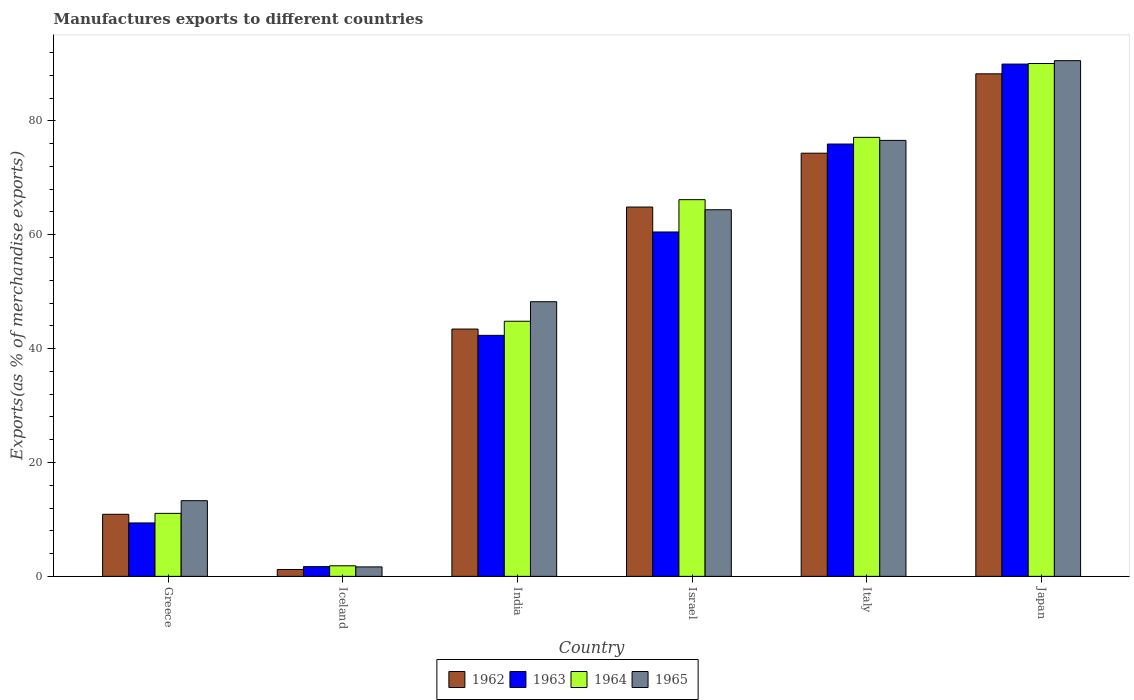How many different coloured bars are there?
Provide a short and direct response. 4. How many groups of bars are there?
Keep it short and to the point. 6. What is the percentage of exports to different countries in 1962 in Israel?
Make the answer very short. 64.86. Across all countries, what is the maximum percentage of exports to different countries in 1963?
Your response must be concise. 89.97. Across all countries, what is the minimum percentage of exports to different countries in 1965?
Make the answer very short. 1.66. In which country was the percentage of exports to different countries in 1965 maximum?
Keep it short and to the point. Japan. In which country was the percentage of exports to different countries in 1962 minimum?
Ensure brevity in your answer.  Iceland. What is the total percentage of exports to different countries in 1964 in the graph?
Provide a succinct answer. 291.06. What is the difference between the percentage of exports to different countries in 1964 in Iceland and that in Israel?
Give a very brief answer. -64.3. What is the difference between the percentage of exports to different countries in 1964 in Iceland and the percentage of exports to different countries in 1962 in Japan?
Give a very brief answer. -86.4. What is the average percentage of exports to different countries in 1965 per country?
Your response must be concise. 49.12. What is the difference between the percentage of exports to different countries of/in 1963 and percentage of exports to different countries of/in 1962 in Italy?
Your response must be concise. 1.61. In how many countries, is the percentage of exports to different countries in 1965 greater than 64 %?
Keep it short and to the point. 3. What is the ratio of the percentage of exports to different countries in 1964 in Iceland to that in India?
Offer a very short reply. 0.04. Is the percentage of exports to different countries in 1964 in Iceland less than that in Italy?
Your response must be concise. Yes. Is the difference between the percentage of exports to different countries in 1963 in Israel and Japan greater than the difference between the percentage of exports to different countries in 1962 in Israel and Japan?
Ensure brevity in your answer.  No. What is the difference between the highest and the second highest percentage of exports to different countries in 1963?
Your answer should be very brief. 14.04. What is the difference between the highest and the lowest percentage of exports to different countries in 1963?
Make the answer very short. 88.26. What does the 3rd bar from the left in Japan represents?
Offer a terse response. 1964. Is it the case that in every country, the sum of the percentage of exports to different countries in 1962 and percentage of exports to different countries in 1965 is greater than the percentage of exports to different countries in 1964?
Your response must be concise. Yes. How many bars are there?
Make the answer very short. 24. What is the difference between two consecutive major ticks on the Y-axis?
Provide a succinct answer. 20. Are the values on the major ticks of Y-axis written in scientific E-notation?
Ensure brevity in your answer.  No. Does the graph contain any zero values?
Keep it short and to the point. No. What is the title of the graph?
Your response must be concise. Manufactures exports to different countries. Does "1967" appear as one of the legend labels in the graph?
Make the answer very short. No. What is the label or title of the Y-axis?
Offer a very short reply. Exports(as % of merchandise exports). What is the Exports(as % of merchandise exports) in 1962 in Greece?
Provide a short and direct response. 10.9. What is the Exports(as % of merchandise exports) in 1963 in Greece?
Your answer should be compact. 9.38. What is the Exports(as % of merchandise exports) of 1964 in Greece?
Keep it short and to the point. 11.06. What is the Exports(as % of merchandise exports) in 1965 in Greece?
Provide a succinct answer. 13.29. What is the Exports(as % of merchandise exports) in 1962 in Iceland?
Your answer should be compact. 1.21. What is the Exports(as % of merchandise exports) in 1963 in Iceland?
Give a very brief answer. 1.71. What is the Exports(as % of merchandise exports) in 1964 in Iceland?
Keep it short and to the point. 1.86. What is the Exports(as % of merchandise exports) of 1965 in Iceland?
Provide a succinct answer. 1.66. What is the Exports(as % of merchandise exports) in 1962 in India?
Provide a short and direct response. 43.43. What is the Exports(as % of merchandise exports) of 1963 in India?
Your answer should be compact. 42.33. What is the Exports(as % of merchandise exports) of 1964 in India?
Make the answer very short. 44.81. What is the Exports(as % of merchandise exports) of 1965 in India?
Ensure brevity in your answer.  48.24. What is the Exports(as % of merchandise exports) in 1962 in Israel?
Provide a short and direct response. 64.86. What is the Exports(as % of merchandise exports) of 1963 in Israel?
Offer a terse response. 60.48. What is the Exports(as % of merchandise exports) in 1964 in Israel?
Ensure brevity in your answer.  66.16. What is the Exports(as % of merchandise exports) of 1965 in Israel?
Your response must be concise. 64.39. What is the Exports(as % of merchandise exports) of 1962 in Italy?
Provide a short and direct response. 74.32. What is the Exports(as % of merchandise exports) in 1963 in Italy?
Your answer should be compact. 75.93. What is the Exports(as % of merchandise exports) of 1964 in Italy?
Ensure brevity in your answer.  77.1. What is the Exports(as % of merchandise exports) of 1965 in Italy?
Your answer should be very brief. 76.57. What is the Exports(as % of merchandise exports) of 1962 in Japan?
Ensure brevity in your answer.  88.26. What is the Exports(as % of merchandise exports) of 1963 in Japan?
Keep it short and to the point. 89.97. What is the Exports(as % of merchandise exports) of 1964 in Japan?
Your answer should be compact. 90.07. What is the Exports(as % of merchandise exports) of 1965 in Japan?
Give a very brief answer. 90.57. Across all countries, what is the maximum Exports(as % of merchandise exports) in 1962?
Offer a very short reply. 88.26. Across all countries, what is the maximum Exports(as % of merchandise exports) of 1963?
Offer a terse response. 89.97. Across all countries, what is the maximum Exports(as % of merchandise exports) of 1964?
Give a very brief answer. 90.07. Across all countries, what is the maximum Exports(as % of merchandise exports) in 1965?
Your response must be concise. 90.57. Across all countries, what is the minimum Exports(as % of merchandise exports) of 1962?
Offer a very short reply. 1.21. Across all countries, what is the minimum Exports(as % of merchandise exports) in 1963?
Provide a short and direct response. 1.71. Across all countries, what is the minimum Exports(as % of merchandise exports) of 1964?
Ensure brevity in your answer.  1.86. Across all countries, what is the minimum Exports(as % of merchandise exports) of 1965?
Your answer should be very brief. 1.66. What is the total Exports(as % of merchandise exports) in 1962 in the graph?
Ensure brevity in your answer.  282.99. What is the total Exports(as % of merchandise exports) in 1963 in the graph?
Give a very brief answer. 279.8. What is the total Exports(as % of merchandise exports) in 1964 in the graph?
Keep it short and to the point. 291.06. What is the total Exports(as % of merchandise exports) of 1965 in the graph?
Make the answer very short. 294.72. What is the difference between the Exports(as % of merchandise exports) of 1962 in Greece and that in Iceland?
Ensure brevity in your answer.  9.69. What is the difference between the Exports(as % of merchandise exports) in 1963 in Greece and that in Iceland?
Give a very brief answer. 7.67. What is the difference between the Exports(as % of merchandise exports) of 1964 in Greece and that in Iceland?
Your response must be concise. 9.21. What is the difference between the Exports(as % of merchandise exports) of 1965 in Greece and that in Iceland?
Make the answer very short. 11.63. What is the difference between the Exports(as % of merchandise exports) in 1962 in Greece and that in India?
Keep it short and to the point. -32.53. What is the difference between the Exports(as % of merchandise exports) in 1963 in Greece and that in India?
Your answer should be very brief. -32.95. What is the difference between the Exports(as % of merchandise exports) in 1964 in Greece and that in India?
Your response must be concise. -33.74. What is the difference between the Exports(as % of merchandise exports) of 1965 in Greece and that in India?
Provide a succinct answer. -34.95. What is the difference between the Exports(as % of merchandise exports) of 1962 in Greece and that in Israel?
Give a very brief answer. -53.96. What is the difference between the Exports(as % of merchandise exports) of 1963 in Greece and that in Israel?
Your answer should be very brief. -51.1. What is the difference between the Exports(as % of merchandise exports) of 1964 in Greece and that in Israel?
Ensure brevity in your answer.  -55.1. What is the difference between the Exports(as % of merchandise exports) of 1965 in Greece and that in Israel?
Your answer should be very brief. -51.1. What is the difference between the Exports(as % of merchandise exports) in 1962 in Greece and that in Italy?
Give a very brief answer. -63.42. What is the difference between the Exports(as % of merchandise exports) in 1963 in Greece and that in Italy?
Your response must be concise. -66.55. What is the difference between the Exports(as % of merchandise exports) in 1964 in Greece and that in Italy?
Ensure brevity in your answer.  -66.04. What is the difference between the Exports(as % of merchandise exports) of 1965 in Greece and that in Italy?
Provide a succinct answer. -63.28. What is the difference between the Exports(as % of merchandise exports) in 1962 in Greece and that in Japan?
Give a very brief answer. -77.36. What is the difference between the Exports(as % of merchandise exports) of 1963 in Greece and that in Japan?
Your answer should be compact. -80.59. What is the difference between the Exports(as % of merchandise exports) in 1964 in Greece and that in Japan?
Ensure brevity in your answer.  -79.01. What is the difference between the Exports(as % of merchandise exports) in 1965 in Greece and that in Japan?
Provide a succinct answer. -77.28. What is the difference between the Exports(as % of merchandise exports) in 1962 in Iceland and that in India?
Provide a short and direct response. -42.22. What is the difference between the Exports(as % of merchandise exports) in 1963 in Iceland and that in India?
Provide a short and direct response. -40.62. What is the difference between the Exports(as % of merchandise exports) of 1964 in Iceland and that in India?
Offer a very short reply. -42.95. What is the difference between the Exports(as % of merchandise exports) in 1965 in Iceland and that in India?
Your answer should be compact. -46.57. What is the difference between the Exports(as % of merchandise exports) of 1962 in Iceland and that in Israel?
Your response must be concise. -63.65. What is the difference between the Exports(as % of merchandise exports) in 1963 in Iceland and that in Israel?
Make the answer very short. -58.77. What is the difference between the Exports(as % of merchandise exports) in 1964 in Iceland and that in Israel?
Provide a short and direct response. -64.3. What is the difference between the Exports(as % of merchandise exports) in 1965 in Iceland and that in Israel?
Offer a very short reply. -62.73. What is the difference between the Exports(as % of merchandise exports) of 1962 in Iceland and that in Italy?
Your answer should be compact. -73.11. What is the difference between the Exports(as % of merchandise exports) in 1963 in Iceland and that in Italy?
Provide a succinct answer. -74.22. What is the difference between the Exports(as % of merchandise exports) of 1964 in Iceland and that in Italy?
Your answer should be very brief. -75.25. What is the difference between the Exports(as % of merchandise exports) in 1965 in Iceland and that in Italy?
Your answer should be compact. -74.9. What is the difference between the Exports(as % of merchandise exports) of 1962 in Iceland and that in Japan?
Give a very brief answer. -87.05. What is the difference between the Exports(as % of merchandise exports) in 1963 in Iceland and that in Japan?
Keep it short and to the point. -88.26. What is the difference between the Exports(as % of merchandise exports) of 1964 in Iceland and that in Japan?
Give a very brief answer. -88.22. What is the difference between the Exports(as % of merchandise exports) in 1965 in Iceland and that in Japan?
Your answer should be very brief. -88.91. What is the difference between the Exports(as % of merchandise exports) in 1962 in India and that in Israel?
Your response must be concise. -21.43. What is the difference between the Exports(as % of merchandise exports) in 1963 in India and that in Israel?
Provide a succinct answer. -18.15. What is the difference between the Exports(as % of merchandise exports) in 1964 in India and that in Israel?
Give a very brief answer. -21.35. What is the difference between the Exports(as % of merchandise exports) in 1965 in India and that in Israel?
Give a very brief answer. -16.15. What is the difference between the Exports(as % of merchandise exports) of 1962 in India and that in Italy?
Your response must be concise. -30.89. What is the difference between the Exports(as % of merchandise exports) of 1963 in India and that in Italy?
Keep it short and to the point. -33.6. What is the difference between the Exports(as % of merchandise exports) of 1964 in India and that in Italy?
Your answer should be compact. -32.3. What is the difference between the Exports(as % of merchandise exports) in 1965 in India and that in Italy?
Keep it short and to the point. -28.33. What is the difference between the Exports(as % of merchandise exports) of 1962 in India and that in Japan?
Provide a short and direct response. -44.83. What is the difference between the Exports(as % of merchandise exports) of 1963 in India and that in Japan?
Give a very brief answer. -47.64. What is the difference between the Exports(as % of merchandise exports) of 1964 in India and that in Japan?
Keep it short and to the point. -45.26. What is the difference between the Exports(as % of merchandise exports) in 1965 in India and that in Japan?
Give a very brief answer. -42.34. What is the difference between the Exports(as % of merchandise exports) in 1962 in Israel and that in Italy?
Offer a terse response. -9.46. What is the difference between the Exports(as % of merchandise exports) of 1963 in Israel and that in Italy?
Provide a short and direct response. -15.45. What is the difference between the Exports(as % of merchandise exports) in 1964 in Israel and that in Italy?
Provide a succinct answer. -10.94. What is the difference between the Exports(as % of merchandise exports) in 1965 in Israel and that in Italy?
Give a very brief answer. -12.18. What is the difference between the Exports(as % of merchandise exports) in 1962 in Israel and that in Japan?
Give a very brief answer. -23.4. What is the difference between the Exports(as % of merchandise exports) of 1963 in Israel and that in Japan?
Keep it short and to the point. -29.49. What is the difference between the Exports(as % of merchandise exports) in 1964 in Israel and that in Japan?
Your answer should be very brief. -23.91. What is the difference between the Exports(as % of merchandise exports) in 1965 in Israel and that in Japan?
Provide a short and direct response. -26.18. What is the difference between the Exports(as % of merchandise exports) of 1962 in Italy and that in Japan?
Your answer should be very brief. -13.94. What is the difference between the Exports(as % of merchandise exports) of 1963 in Italy and that in Japan?
Keep it short and to the point. -14.04. What is the difference between the Exports(as % of merchandise exports) in 1964 in Italy and that in Japan?
Offer a terse response. -12.97. What is the difference between the Exports(as % of merchandise exports) in 1965 in Italy and that in Japan?
Offer a terse response. -14.01. What is the difference between the Exports(as % of merchandise exports) of 1962 in Greece and the Exports(as % of merchandise exports) of 1963 in Iceland?
Ensure brevity in your answer.  9.19. What is the difference between the Exports(as % of merchandise exports) in 1962 in Greece and the Exports(as % of merchandise exports) in 1964 in Iceland?
Keep it short and to the point. 9.05. What is the difference between the Exports(as % of merchandise exports) of 1962 in Greece and the Exports(as % of merchandise exports) of 1965 in Iceland?
Provide a succinct answer. 9.24. What is the difference between the Exports(as % of merchandise exports) in 1963 in Greece and the Exports(as % of merchandise exports) in 1964 in Iceland?
Your answer should be very brief. 7.52. What is the difference between the Exports(as % of merchandise exports) of 1963 in Greece and the Exports(as % of merchandise exports) of 1965 in Iceland?
Offer a very short reply. 7.72. What is the difference between the Exports(as % of merchandise exports) in 1964 in Greece and the Exports(as % of merchandise exports) in 1965 in Iceland?
Your answer should be very brief. 9.4. What is the difference between the Exports(as % of merchandise exports) of 1962 in Greece and the Exports(as % of merchandise exports) of 1963 in India?
Make the answer very short. -31.43. What is the difference between the Exports(as % of merchandise exports) of 1962 in Greece and the Exports(as % of merchandise exports) of 1964 in India?
Your answer should be compact. -33.91. What is the difference between the Exports(as % of merchandise exports) of 1962 in Greece and the Exports(as % of merchandise exports) of 1965 in India?
Provide a succinct answer. -37.33. What is the difference between the Exports(as % of merchandise exports) of 1963 in Greece and the Exports(as % of merchandise exports) of 1964 in India?
Your answer should be very brief. -35.43. What is the difference between the Exports(as % of merchandise exports) in 1963 in Greece and the Exports(as % of merchandise exports) in 1965 in India?
Give a very brief answer. -38.86. What is the difference between the Exports(as % of merchandise exports) in 1964 in Greece and the Exports(as % of merchandise exports) in 1965 in India?
Ensure brevity in your answer.  -37.17. What is the difference between the Exports(as % of merchandise exports) of 1962 in Greece and the Exports(as % of merchandise exports) of 1963 in Israel?
Provide a succinct answer. -49.58. What is the difference between the Exports(as % of merchandise exports) of 1962 in Greece and the Exports(as % of merchandise exports) of 1964 in Israel?
Provide a succinct answer. -55.26. What is the difference between the Exports(as % of merchandise exports) in 1962 in Greece and the Exports(as % of merchandise exports) in 1965 in Israel?
Give a very brief answer. -53.49. What is the difference between the Exports(as % of merchandise exports) in 1963 in Greece and the Exports(as % of merchandise exports) in 1964 in Israel?
Keep it short and to the point. -56.78. What is the difference between the Exports(as % of merchandise exports) of 1963 in Greece and the Exports(as % of merchandise exports) of 1965 in Israel?
Make the answer very short. -55.01. What is the difference between the Exports(as % of merchandise exports) of 1964 in Greece and the Exports(as % of merchandise exports) of 1965 in Israel?
Offer a terse response. -53.33. What is the difference between the Exports(as % of merchandise exports) of 1962 in Greece and the Exports(as % of merchandise exports) of 1963 in Italy?
Provide a succinct answer. -65.03. What is the difference between the Exports(as % of merchandise exports) of 1962 in Greece and the Exports(as % of merchandise exports) of 1964 in Italy?
Give a very brief answer. -66.2. What is the difference between the Exports(as % of merchandise exports) in 1962 in Greece and the Exports(as % of merchandise exports) in 1965 in Italy?
Offer a terse response. -65.66. What is the difference between the Exports(as % of merchandise exports) in 1963 in Greece and the Exports(as % of merchandise exports) in 1964 in Italy?
Make the answer very short. -67.72. What is the difference between the Exports(as % of merchandise exports) of 1963 in Greece and the Exports(as % of merchandise exports) of 1965 in Italy?
Offer a terse response. -67.19. What is the difference between the Exports(as % of merchandise exports) of 1964 in Greece and the Exports(as % of merchandise exports) of 1965 in Italy?
Make the answer very short. -65.5. What is the difference between the Exports(as % of merchandise exports) of 1962 in Greece and the Exports(as % of merchandise exports) of 1963 in Japan?
Your response must be concise. -79.07. What is the difference between the Exports(as % of merchandise exports) in 1962 in Greece and the Exports(as % of merchandise exports) in 1964 in Japan?
Keep it short and to the point. -79.17. What is the difference between the Exports(as % of merchandise exports) of 1962 in Greece and the Exports(as % of merchandise exports) of 1965 in Japan?
Provide a succinct answer. -79.67. What is the difference between the Exports(as % of merchandise exports) in 1963 in Greece and the Exports(as % of merchandise exports) in 1964 in Japan?
Your response must be concise. -80.69. What is the difference between the Exports(as % of merchandise exports) of 1963 in Greece and the Exports(as % of merchandise exports) of 1965 in Japan?
Ensure brevity in your answer.  -81.19. What is the difference between the Exports(as % of merchandise exports) of 1964 in Greece and the Exports(as % of merchandise exports) of 1965 in Japan?
Give a very brief answer. -79.51. What is the difference between the Exports(as % of merchandise exports) in 1962 in Iceland and the Exports(as % of merchandise exports) in 1963 in India?
Ensure brevity in your answer.  -41.12. What is the difference between the Exports(as % of merchandise exports) of 1962 in Iceland and the Exports(as % of merchandise exports) of 1964 in India?
Provide a succinct answer. -43.6. What is the difference between the Exports(as % of merchandise exports) in 1962 in Iceland and the Exports(as % of merchandise exports) in 1965 in India?
Ensure brevity in your answer.  -47.03. What is the difference between the Exports(as % of merchandise exports) in 1963 in Iceland and the Exports(as % of merchandise exports) in 1964 in India?
Provide a succinct answer. -43.1. What is the difference between the Exports(as % of merchandise exports) of 1963 in Iceland and the Exports(as % of merchandise exports) of 1965 in India?
Your answer should be very brief. -46.53. What is the difference between the Exports(as % of merchandise exports) of 1964 in Iceland and the Exports(as % of merchandise exports) of 1965 in India?
Provide a short and direct response. -46.38. What is the difference between the Exports(as % of merchandise exports) in 1962 in Iceland and the Exports(as % of merchandise exports) in 1963 in Israel?
Your answer should be very brief. -59.27. What is the difference between the Exports(as % of merchandise exports) of 1962 in Iceland and the Exports(as % of merchandise exports) of 1964 in Israel?
Offer a terse response. -64.95. What is the difference between the Exports(as % of merchandise exports) in 1962 in Iceland and the Exports(as % of merchandise exports) in 1965 in Israel?
Give a very brief answer. -63.18. What is the difference between the Exports(as % of merchandise exports) in 1963 in Iceland and the Exports(as % of merchandise exports) in 1964 in Israel?
Provide a short and direct response. -64.45. What is the difference between the Exports(as % of merchandise exports) of 1963 in Iceland and the Exports(as % of merchandise exports) of 1965 in Israel?
Provide a short and direct response. -62.68. What is the difference between the Exports(as % of merchandise exports) of 1964 in Iceland and the Exports(as % of merchandise exports) of 1965 in Israel?
Provide a short and direct response. -62.53. What is the difference between the Exports(as % of merchandise exports) in 1962 in Iceland and the Exports(as % of merchandise exports) in 1963 in Italy?
Ensure brevity in your answer.  -74.72. What is the difference between the Exports(as % of merchandise exports) of 1962 in Iceland and the Exports(as % of merchandise exports) of 1964 in Italy?
Your answer should be compact. -75.89. What is the difference between the Exports(as % of merchandise exports) of 1962 in Iceland and the Exports(as % of merchandise exports) of 1965 in Italy?
Offer a terse response. -75.36. What is the difference between the Exports(as % of merchandise exports) in 1963 in Iceland and the Exports(as % of merchandise exports) in 1964 in Italy?
Offer a very short reply. -75.39. What is the difference between the Exports(as % of merchandise exports) of 1963 in Iceland and the Exports(as % of merchandise exports) of 1965 in Italy?
Offer a terse response. -74.86. What is the difference between the Exports(as % of merchandise exports) in 1964 in Iceland and the Exports(as % of merchandise exports) in 1965 in Italy?
Your answer should be compact. -74.71. What is the difference between the Exports(as % of merchandise exports) in 1962 in Iceland and the Exports(as % of merchandise exports) in 1963 in Japan?
Your response must be concise. -88.76. What is the difference between the Exports(as % of merchandise exports) in 1962 in Iceland and the Exports(as % of merchandise exports) in 1964 in Japan?
Give a very brief answer. -88.86. What is the difference between the Exports(as % of merchandise exports) in 1962 in Iceland and the Exports(as % of merchandise exports) in 1965 in Japan?
Provide a short and direct response. -89.36. What is the difference between the Exports(as % of merchandise exports) in 1963 in Iceland and the Exports(as % of merchandise exports) in 1964 in Japan?
Offer a very short reply. -88.36. What is the difference between the Exports(as % of merchandise exports) in 1963 in Iceland and the Exports(as % of merchandise exports) in 1965 in Japan?
Provide a short and direct response. -88.86. What is the difference between the Exports(as % of merchandise exports) of 1964 in Iceland and the Exports(as % of merchandise exports) of 1965 in Japan?
Give a very brief answer. -88.72. What is the difference between the Exports(as % of merchandise exports) of 1962 in India and the Exports(as % of merchandise exports) of 1963 in Israel?
Ensure brevity in your answer.  -17.05. What is the difference between the Exports(as % of merchandise exports) of 1962 in India and the Exports(as % of merchandise exports) of 1964 in Israel?
Offer a terse response. -22.73. What is the difference between the Exports(as % of merchandise exports) of 1962 in India and the Exports(as % of merchandise exports) of 1965 in Israel?
Your response must be concise. -20.96. What is the difference between the Exports(as % of merchandise exports) of 1963 in India and the Exports(as % of merchandise exports) of 1964 in Israel?
Your answer should be compact. -23.83. What is the difference between the Exports(as % of merchandise exports) of 1963 in India and the Exports(as % of merchandise exports) of 1965 in Israel?
Offer a terse response. -22.06. What is the difference between the Exports(as % of merchandise exports) of 1964 in India and the Exports(as % of merchandise exports) of 1965 in Israel?
Keep it short and to the point. -19.58. What is the difference between the Exports(as % of merchandise exports) of 1962 in India and the Exports(as % of merchandise exports) of 1963 in Italy?
Offer a terse response. -32.49. What is the difference between the Exports(as % of merchandise exports) of 1962 in India and the Exports(as % of merchandise exports) of 1964 in Italy?
Offer a terse response. -33.67. What is the difference between the Exports(as % of merchandise exports) in 1962 in India and the Exports(as % of merchandise exports) in 1965 in Italy?
Offer a terse response. -33.13. What is the difference between the Exports(as % of merchandise exports) in 1963 in India and the Exports(as % of merchandise exports) in 1964 in Italy?
Your response must be concise. -34.77. What is the difference between the Exports(as % of merchandise exports) in 1963 in India and the Exports(as % of merchandise exports) in 1965 in Italy?
Give a very brief answer. -34.24. What is the difference between the Exports(as % of merchandise exports) of 1964 in India and the Exports(as % of merchandise exports) of 1965 in Italy?
Offer a very short reply. -31.76. What is the difference between the Exports(as % of merchandise exports) in 1962 in India and the Exports(as % of merchandise exports) in 1963 in Japan?
Offer a terse response. -46.54. What is the difference between the Exports(as % of merchandise exports) of 1962 in India and the Exports(as % of merchandise exports) of 1964 in Japan?
Provide a short and direct response. -46.64. What is the difference between the Exports(as % of merchandise exports) of 1962 in India and the Exports(as % of merchandise exports) of 1965 in Japan?
Your answer should be compact. -47.14. What is the difference between the Exports(as % of merchandise exports) of 1963 in India and the Exports(as % of merchandise exports) of 1964 in Japan?
Provide a short and direct response. -47.74. What is the difference between the Exports(as % of merchandise exports) in 1963 in India and the Exports(as % of merchandise exports) in 1965 in Japan?
Ensure brevity in your answer.  -48.24. What is the difference between the Exports(as % of merchandise exports) of 1964 in India and the Exports(as % of merchandise exports) of 1965 in Japan?
Keep it short and to the point. -45.76. What is the difference between the Exports(as % of merchandise exports) of 1962 in Israel and the Exports(as % of merchandise exports) of 1963 in Italy?
Provide a succinct answer. -11.07. What is the difference between the Exports(as % of merchandise exports) in 1962 in Israel and the Exports(as % of merchandise exports) in 1964 in Italy?
Make the answer very short. -12.24. What is the difference between the Exports(as % of merchandise exports) in 1962 in Israel and the Exports(as % of merchandise exports) in 1965 in Italy?
Offer a very short reply. -11.7. What is the difference between the Exports(as % of merchandise exports) of 1963 in Israel and the Exports(as % of merchandise exports) of 1964 in Italy?
Give a very brief answer. -16.62. What is the difference between the Exports(as % of merchandise exports) of 1963 in Israel and the Exports(as % of merchandise exports) of 1965 in Italy?
Ensure brevity in your answer.  -16.08. What is the difference between the Exports(as % of merchandise exports) of 1964 in Israel and the Exports(as % of merchandise exports) of 1965 in Italy?
Keep it short and to the point. -10.41. What is the difference between the Exports(as % of merchandise exports) of 1962 in Israel and the Exports(as % of merchandise exports) of 1963 in Japan?
Keep it short and to the point. -25.11. What is the difference between the Exports(as % of merchandise exports) of 1962 in Israel and the Exports(as % of merchandise exports) of 1964 in Japan?
Offer a terse response. -25.21. What is the difference between the Exports(as % of merchandise exports) of 1962 in Israel and the Exports(as % of merchandise exports) of 1965 in Japan?
Your answer should be compact. -25.71. What is the difference between the Exports(as % of merchandise exports) in 1963 in Israel and the Exports(as % of merchandise exports) in 1964 in Japan?
Provide a succinct answer. -29.59. What is the difference between the Exports(as % of merchandise exports) in 1963 in Israel and the Exports(as % of merchandise exports) in 1965 in Japan?
Keep it short and to the point. -30.09. What is the difference between the Exports(as % of merchandise exports) of 1964 in Israel and the Exports(as % of merchandise exports) of 1965 in Japan?
Your answer should be very brief. -24.41. What is the difference between the Exports(as % of merchandise exports) of 1962 in Italy and the Exports(as % of merchandise exports) of 1963 in Japan?
Keep it short and to the point. -15.65. What is the difference between the Exports(as % of merchandise exports) of 1962 in Italy and the Exports(as % of merchandise exports) of 1964 in Japan?
Provide a succinct answer. -15.75. What is the difference between the Exports(as % of merchandise exports) in 1962 in Italy and the Exports(as % of merchandise exports) in 1965 in Japan?
Make the answer very short. -16.25. What is the difference between the Exports(as % of merchandise exports) of 1963 in Italy and the Exports(as % of merchandise exports) of 1964 in Japan?
Provide a short and direct response. -14.14. What is the difference between the Exports(as % of merchandise exports) in 1963 in Italy and the Exports(as % of merchandise exports) in 1965 in Japan?
Make the answer very short. -14.64. What is the difference between the Exports(as % of merchandise exports) in 1964 in Italy and the Exports(as % of merchandise exports) in 1965 in Japan?
Your answer should be compact. -13.47. What is the average Exports(as % of merchandise exports) in 1962 per country?
Your answer should be compact. 47.17. What is the average Exports(as % of merchandise exports) in 1963 per country?
Provide a succinct answer. 46.63. What is the average Exports(as % of merchandise exports) in 1964 per country?
Ensure brevity in your answer.  48.51. What is the average Exports(as % of merchandise exports) in 1965 per country?
Give a very brief answer. 49.12. What is the difference between the Exports(as % of merchandise exports) in 1962 and Exports(as % of merchandise exports) in 1963 in Greece?
Ensure brevity in your answer.  1.52. What is the difference between the Exports(as % of merchandise exports) in 1962 and Exports(as % of merchandise exports) in 1964 in Greece?
Offer a very short reply. -0.16. What is the difference between the Exports(as % of merchandise exports) of 1962 and Exports(as % of merchandise exports) of 1965 in Greece?
Your answer should be compact. -2.39. What is the difference between the Exports(as % of merchandise exports) of 1963 and Exports(as % of merchandise exports) of 1964 in Greece?
Provide a short and direct response. -1.68. What is the difference between the Exports(as % of merchandise exports) in 1963 and Exports(as % of merchandise exports) in 1965 in Greece?
Your response must be concise. -3.91. What is the difference between the Exports(as % of merchandise exports) of 1964 and Exports(as % of merchandise exports) of 1965 in Greece?
Your answer should be very brief. -2.23. What is the difference between the Exports(as % of merchandise exports) of 1962 and Exports(as % of merchandise exports) of 1963 in Iceland?
Ensure brevity in your answer.  -0.5. What is the difference between the Exports(as % of merchandise exports) of 1962 and Exports(as % of merchandise exports) of 1964 in Iceland?
Your answer should be very brief. -0.65. What is the difference between the Exports(as % of merchandise exports) of 1962 and Exports(as % of merchandise exports) of 1965 in Iceland?
Keep it short and to the point. -0.45. What is the difference between the Exports(as % of merchandise exports) of 1963 and Exports(as % of merchandise exports) of 1964 in Iceland?
Make the answer very short. -0.15. What is the difference between the Exports(as % of merchandise exports) of 1963 and Exports(as % of merchandise exports) of 1965 in Iceland?
Make the answer very short. 0.05. What is the difference between the Exports(as % of merchandise exports) in 1964 and Exports(as % of merchandise exports) in 1965 in Iceland?
Offer a terse response. 0.19. What is the difference between the Exports(as % of merchandise exports) of 1962 and Exports(as % of merchandise exports) of 1963 in India?
Your response must be concise. 1.11. What is the difference between the Exports(as % of merchandise exports) in 1962 and Exports(as % of merchandise exports) in 1964 in India?
Provide a succinct answer. -1.37. What is the difference between the Exports(as % of merchandise exports) in 1962 and Exports(as % of merchandise exports) in 1965 in India?
Make the answer very short. -4.8. What is the difference between the Exports(as % of merchandise exports) in 1963 and Exports(as % of merchandise exports) in 1964 in India?
Provide a succinct answer. -2.48. What is the difference between the Exports(as % of merchandise exports) in 1963 and Exports(as % of merchandise exports) in 1965 in India?
Your response must be concise. -5.91. What is the difference between the Exports(as % of merchandise exports) in 1964 and Exports(as % of merchandise exports) in 1965 in India?
Make the answer very short. -3.43. What is the difference between the Exports(as % of merchandise exports) of 1962 and Exports(as % of merchandise exports) of 1963 in Israel?
Provide a succinct answer. 4.38. What is the difference between the Exports(as % of merchandise exports) in 1962 and Exports(as % of merchandise exports) in 1964 in Israel?
Your response must be concise. -1.3. What is the difference between the Exports(as % of merchandise exports) in 1962 and Exports(as % of merchandise exports) in 1965 in Israel?
Offer a very short reply. 0.47. What is the difference between the Exports(as % of merchandise exports) of 1963 and Exports(as % of merchandise exports) of 1964 in Israel?
Keep it short and to the point. -5.68. What is the difference between the Exports(as % of merchandise exports) of 1963 and Exports(as % of merchandise exports) of 1965 in Israel?
Your response must be concise. -3.91. What is the difference between the Exports(as % of merchandise exports) in 1964 and Exports(as % of merchandise exports) in 1965 in Israel?
Your answer should be compact. 1.77. What is the difference between the Exports(as % of merchandise exports) of 1962 and Exports(as % of merchandise exports) of 1963 in Italy?
Ensure brevity in your answer.  -1.61. What is the difference between the Exports(as % of merchandise exports) in 1962 and Exports(as % of merchandise exports) in 1964 in Italy?
Your answer should be compact. -2.78. What is the difference between the Exports(as % of merchandise exports) in 1962 and Exports(as % of merchandise exports) in 1965 in Italy?
Your response must be concise. -2.25. What is the difference between the Exports(as % of merchandise exports) of 1963 and Exports(as % of merchandise exports) of 1964 in Italy?
Provide a short and direct response. -1.17. What is the difference between the Exports(as % of merchandise exports) of 1963 and Exports(as % of merchandise exports) of 1965 in Italy?
Give a very brief answer. -0.64. What is the difference between the Exports(as % of merchandise exports) in 1964 and Exports(as % of merchandise exports) in 1965 in Italy?
Your answer should be very brief. 0.54. What is the difference between the Exports(as % of merchandise exports) of 1962 and Exports(as % of merchandise exports) of 1963 in Japan?
Your response must be concise. -1.71. What is the difference between the Exports(as % of merchandise exports) of 1962 and Exports(as % of merchandise exports) of 1964 in Japan?
Ensure brevity in your answer.  -1.81. What is the difference between the Exports(as % of merchandise exports) in 1962 and Exports(as % of merchandise exports) in 1965 in Japan?
Ensure brevity in your answer.  -2.31. What is the difference between the Exports(as % of merchandise exports) in 1963 and Exports(as % of merchandise exports) in 1964 in Japan?
Offer a terse response. -0.1. What is the difference between the Exports(as % of merchandise exports) in 1963 and Exports(as % of merchandise exports) in 1965 in Japan?
Keep it short and to the point. -0.6. What is the difference between the Exports(as % of merchandise exports) of 1964 and Exports(as % of merchandise exports) of 1965 in Japan?
Your answer should be compact. -0.5. What is the ratio of the Exports(as % of merchandise exports) of 1962 in Greece to that in Iceland?
Give a very brief answer. 9.01. What is the ratio of the Exports(as % of merchandise exports) of 1963 in Greece to that in Iceland?
Give a very brief answer. 5.49. What is the ratio of the Exports(as % of merchandise exports) in 1964 in Greece to that in Iceland?
Your response must be concise. 5.96. What is the ratio of the Exports(as % of merchandise exports) of 1965 in Greece to that in Iceland?
Make the answer very short. 7.99. What is the ratio of the Exports(as % of merchandise exports) in 1962 in Greece to that in India?
Keep it short and to the point. 0.25. What is the ratio of the Exports(as % of merchandise exports) in 1963 in Greece to that in India?
Give a very brief answer. 0.22. What is the ratio of the Exports(as % of merchandise exports) of 1964 in Greece to that in India?
Give a very brief answer. 0.25. What is the ratio of the Exports(as % of merchandise exports) of 1965 in Greece to that in India?
Offer a terse response. 0.28. What is the ratio of the Exports(as % of merchandise exports) in 1962 in Greece to that in Israel?
Your answer should be compact. 0.17. What is the ratio of the Exports(as % of merchandise exports) in 1963 in Greece to that in Israel?
Your response must be concise. 0.16. What is the ratio of the Exports(as % of merchandise exports) in 1964 in Greece to that in Israel?
Provide a short and direct response. 0.17. What is the ratio of the Exports(as % of merchandise exports) in 1965 in Greece to that in Israel?
Make the answer very short. 0.21. What is the ratio of the Exports(as % of merchandise exports) of 1962 in Greece to that in Italy?
Make the answer very short. 0.15. What is the ratio of the Exports(as % of merchandise exports) of 1963 in Greece to that in Italy?
Your answer should be compact. 0.12. What is the ratio of the Exports(as % of merchandise exports) in 1964 in Greece to that in Italy?
Your answer should be compact. 0.14. What is the ratio of the Exports(as % of merchandise exports) in 1965 in Greece to that in Italy?
Your answer should be compact. 0.17. What is the ratio of the Exports(as % of merchandise exports) of 1962 in Greece to that in Japan?
Offer a terse response. 0.12. What is the ratio of the Exports(as % of merchandise exports) in 1963 in Greece to that in Japan?
Provide a short and direct response. 0.1. What is the ratio of the Exports(as % of merchandise exports) of 1964 in Greece to that in Japan?
Provide a short and direct response. 0.12. What is the ratio of the Exports(as % of merchandise exports) of 1965 in Greece to that in Japan?
Keep it short and to the point. 0.15. What is the ratio of the Exports(as % of merchandise exports) in 1962 in Iceland to that in India?
Keep it short and to the point. 0.03. What is the ratio of the Exports(as % of merchandise exports) of 1963 in Iceland to that in India?
Ensure brevity in your answer.  0.04. What is the ratio of the Exports(as % of merchandise exports) in 1964 in Iceland to that in India?
Offer a terse response. 0.04. What is the ratio of the Exports(as % of merchandise exports) in 1965 in Iceland to that in India?
Offer a very short reply. 0.03. What is the ratio of the Exports(as % of merchandise exports) of 1962 in Iceland to that in Israel?
Your answer should be compact. 0.02. What is the ratio of the Exports(as % of merchandise exports) in 1963 in Iceland to that in Israel?
Offer a very short reply. 0.03. What is the ratio of the Exports(as % of merchandise exports) in 1964 in Iceland to that in Israel?
Your answer should be very brief. 0.03. What is the ratio of the Exports(as % of merchandise exports) of 1965 in Iceland to that in Israel?
Ensure brevity in your answer.  0.03. What is the ratio of the Exports(as % of merchandise exports) in 1962 in Iceland to that in Italy?
Keep it short and to the point. 0.02. What is the ratio of the Exports(as % of merchandise exports) in 1963 in Iceland to that in Italy?
Provide a short and direct response. 0.02. What is the ratio of the Exports(as % of merchandise exports) of 1964 in Iceland to that in Italy?
Your response must be concise. 0.02. What is the ratio of the Exports(as % of merchandise exports) of 1965 in Iceland to that in Italy?
Your answer should be very brief. 0.02. What is the ratio of the Exports(as % of merchandise exports) of 1962 in Iceland to that in Japan?
Your response must be concise. 0.01. What is the ratio of the Exports(as % of merchandise exports) in 1963 in Iceland to that in Japan?
Provide a short and direct response. 0.02. What is the ratio of the Exports(as % of merchandise exports) in 1964 in Iceland to that in Japan?
Provide a succinct answer. 0.02. What is the ratio of the Exports(as % of merchandise exports) of 1965 in Iceland to that in Japan?
Make the answer very short. 0.02. What is the ratio of the Exports(as % of merchandise exports) in 1962 in India to that in Israel?
Offer a terse response. 0.67. What is the ratio of the Exports(as % of merchandise exports) of 1963 in India to that in Israel?
Make the answer very short. 0.7. What is the ratio of the Exports(as % of merchandise exports) in 1964 in India to that in Israel?
Your answer should be very brief. 0.68. What is the ratio of the Exports(as % of merchandise exports) in 1965 in India to that in Israel?
Give a very brief answer. 0.75. What is the ratio of the Exports(as % of merchandise exports) in 1962 in India to that in Italy?
Your response must be concise. 0.58. What is the ratio of the Exports(as % of merchandise exports) of 1963 in India to that in Italy?
Provide a succinct answer. 0.56. What is the ratio of the Exports(as % of merchandise exports) of 1964 in India to that in Italy?
Provide a succinct answer. 0.58. What is the ratio of the Exports(as % of merchandise exports) in 1965 in India to that in Italy?
Offer a terse response. 0.63. What is the ratio of the Exports(as % of merchandise exports) of 1962 in India to that in Japan?
Ensure brevity in your answer.  0.49. What is the ratio of the Exports(as % of merchandise exports) of 1963 in India to that in Japan?
Give a very brief answer. 0.47. What is the ratio of the Exports(as % of merchandise exports) in 1964 in India to that in Japan?
Provide a short and direct response. 0.5. What is the ratio of the Exports(as % of merchandise exports) in 1965 in India to that in Japan?
Give a very brief answer. 0.53. What is the ratio of the Exports(as % of merchandise exports) of 1962 in Israel to that in Italy?
Ensure brevity in your answer.  0.87. What is the ratio of the Exports(as % of merchandise exports) of 1963 in Israel to that in Italy?
Offer a very short reply. 0.8. What is the ratio of the Exports(as % of merchandise exports) of 1964 in Israel to that in Italy?
Provide a succinct answer. 0.86. What is the ratio of the Exports(as % of merchandise exports) of 1965 in Israel to that in Italy?
Give a very brief answer. 0.84. What is the ratio of the Exports(as % of merchandise exports) of 1962 in Israel to that in Japan?
Ensure brevity in your answer.  0.73. What is the ratio of the Exports(as % of merchandise exports) in 1963 in Israel to that in Japan?
Ensure brevity in your answer.  0.67. What is the ratio of the Exports(as % of merchandise exports) in 1964 in Israel to that in Japan?
Offer a very short reply. 0.73. What is the ratio of the Exports(as % of merchandise exports) in 1965 in Israel to that in Japan?
Offer a terse response. 0.71. What is the ratio of the Exports(as % of merchandise exports) in 1962 in Italy to that in Japan?
Ensure brevity in your answer.  0.84. What is the ratio of the Exports(as % of merchandise exports) in 1963 in Italy to that in Japan?
Your answer should be compact. 0.84. What is the ratio of the Exports(as % of merchandise exports) in 1964 in Italy to that in Japan?
Your answer should be very brief. 0.86. What is the ratio of the Exports(as % of merchandise exports) in 1965 in Italy to that in Japan?
Provide a succinct answer. 0.85. What is the difference between the highest and the second highest Exports(as % of merchandise exports) in 1962?
Your answer should be compact. 13.94. What is the difference between the highest and the second highest Exports(as % of merchandise exports) of 1963?
Make the answer very short. 14.04. What is the difference between the highest and the second highest Exports(as % of merchandise exports) in 1964?
Your answer should be compact. 12.97. What is the difference between the highest and the second highest Exports(as % of merchandise exports) in 1965?
Make the answer very short. 14.01. What is the difference between the highest and the lowest Exports(as % of merchandise exports) of 1962?
Provide a short and direct response. 87.05. What is the difference between the highest and the lowest Exports(as % of merchandise exports) of 1963?
Ensure brevity in your answer.  88.26. What is the difference between the highest and the lowest Exports(as % of merchandise exports) of 1964?
Your response must be concise. 88.22. What is the difference between the highest and the lowest Exports(as % of merchandise exports) of 1965?
Offer a very short reply. 88.91. 